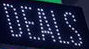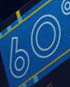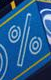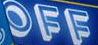What text appears in these images from left to right, separated by a semicolon? DEALS; 60; %; OFF 